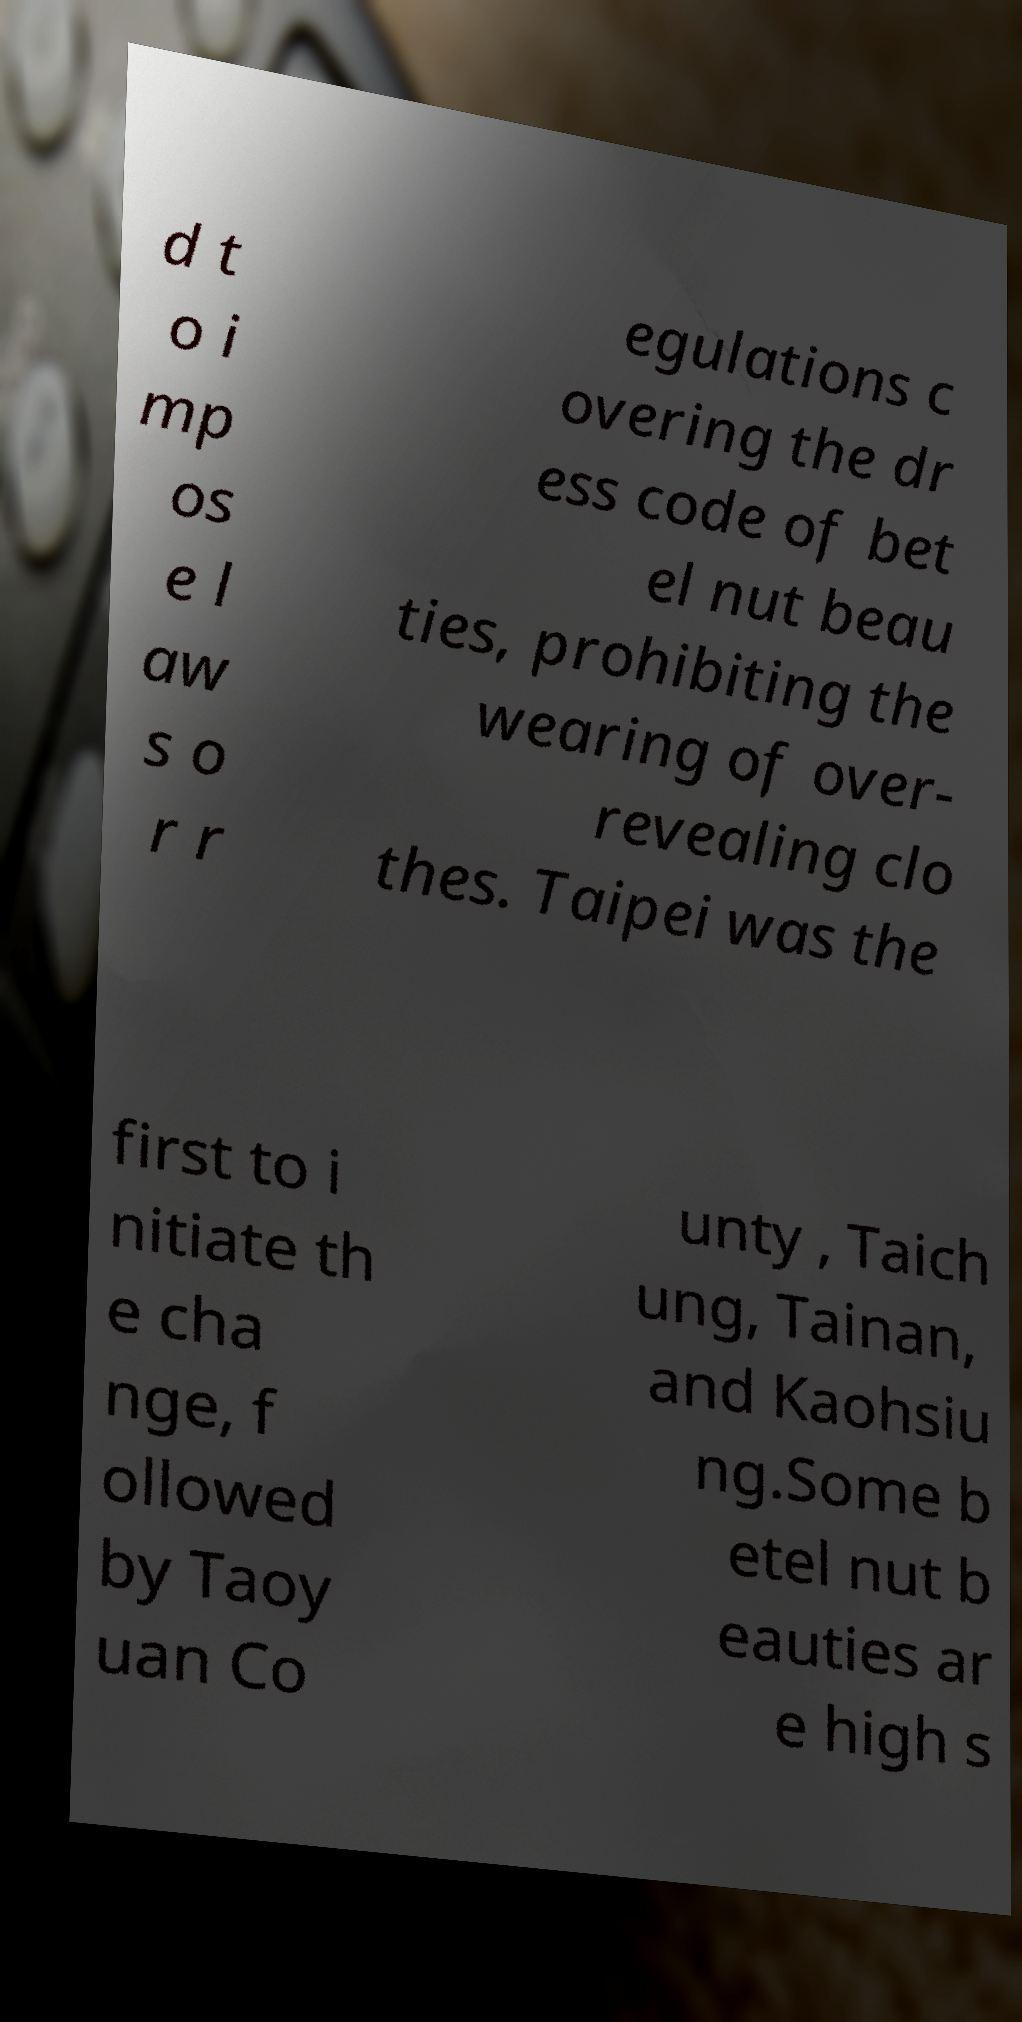There's text embedded in this image that I need extracted. Can you transcribe it verbatim? d t o i mp os e l aw s o r r egulations c overing the dr ess code of bet el nut beau ties, prohibiting the wearing of over- revealing clo thes. Taipei was the first to i nitiate th e cha nge, f ollowed by Taoy uan Co unty , Taich ung, Tainan, and Kaohsiu ng.Some b etel nut b eauties ar e high s 